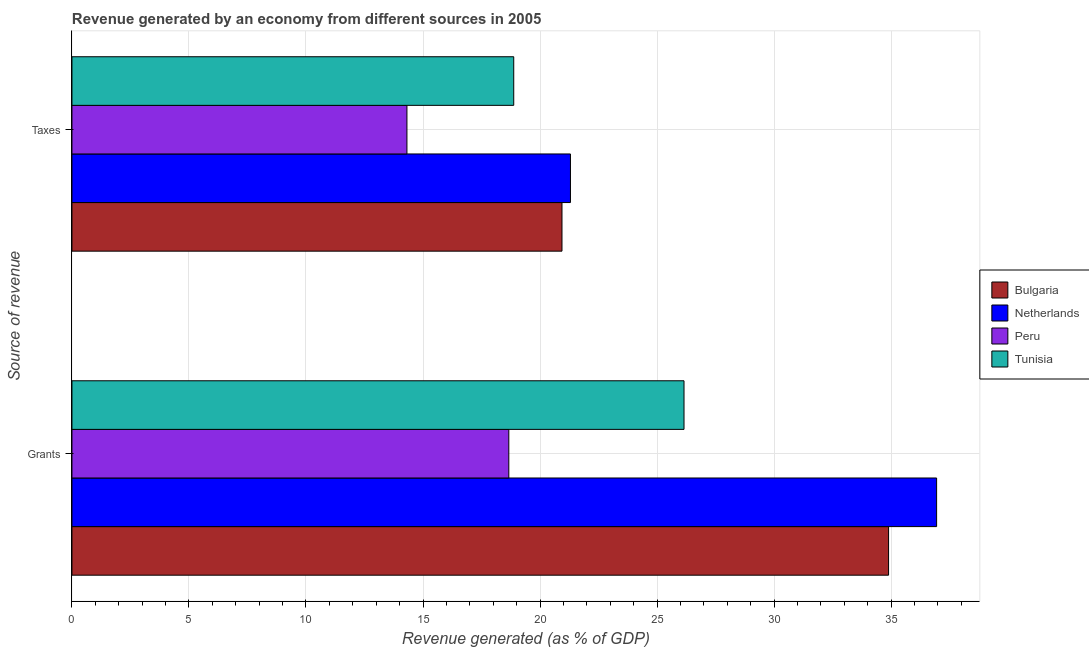Are the number of bars per tick equal to the number of legend labels?
Provide a short and direct response. Yes. How many bars are there on the 1st tick from the top?
Provide a short and direct response. 4. What is the label of the 2nd group of bars from the top?
Your answer should be very brief. Grants. What is the revenue generated by taxes in Peru?
Offer a very short reply. 14.31. Across all countries, what is the maximum revenue generated by grants?
Make the answer very short. 36.95. Across all countries, what is the minimum revenue generated by taxes?
Give a very brief answer. 14.31. What is the total revenue generated by grants in the graph?
Your response must be concise. 116.66. What is the difference between the revenue generated by taxes in Peru and that in Tunisia?
Your answer should be compact. -4.56. What is the difference between the revenue generated by taxes in Peru and the revenue generated by grants in Bulgaria?
Offer a very short reply. -20.58. What is the average revenue generated by grants per country?
Your answer should be compact. 29.17. What is the difference between the revenue generated by grants and revenue generated by taxes in Bulgaria?
Offer a terse response. 13.95. What is the ratio of the revenue generated by taxes in Bulgaria to that in Tunisia?
Your answer should be compact. 1.11. In how many countries, is the revenue generated by taxes greater than the average revenue generated by taxes taken over all countries?
Your response must be concise. 3. What does the 3rd bar from the bottom in Grants represents?
Your response must be concise. Peru. How many bars are there?
Ensure brevity in your answer.  8. Are all the bars in the graph horizontal?
Ensure brevity in your answer.  Yes. How many countries are there in the graph?
Offer a very short reply. 4. Are the values on the major ticks of X-axis written in scientific E-notation?
Offer a terse response. No. Does the graph contain any zero values?
Give a very brief answer. No. Where does the legend appear in the graph?
Give a very brief answer. Center right. How many legend labels are there?
Offer a terse response. 4. How are the legend labels stacked?
Give a very brief answer. Vertical. What is the title of the graph?
Give a very brief answer. Revenue generated by an economy from different sources in 2005. Does "Sierra Leone" appear as one of the legend labels in the graph?
Make the answer very short. No. What is the label or title of the X-axis?
Your response must be concise. Revenue generated (as % of GDP). What is the label or title of the Y-axis?
Keep it short and to the point. Source of revenue. What is the Revenue generated (as % of GDP) of Bulgaria in Grants?
Provide a succinct answer. 34.89. What is the Revenue generated (as % of GDP) of Netherlands in Grants?
Ensure brevity in your answer.  36.95. What is the Revenue generated (as % of GDP) of Peru in Grants?
Your answer should be very brief. 18.67. What is the Revenue generated (as % of GDP) of Tunisia in Grants?
Your answer should be compact. 26.15. What is the Revenue generated (as % of GDP) of Bulgaria in Taxes?
Make the answer very short. 20.94. What is the Revenue generated (as % of GDP) of Netherlands in Taxes?
Make the answer very short. 21.3. What is the Revenue generated (as % of GDP) of Peru in Taxes?
Make the answer very short. 14.31. What is the Revenue generated (as % of GDP) in Tunisia in Taxes?
Provide a short and direct response. 18.88. Across all Source of revenue, what is the maximum Revenue generated (as % of GDP) of Bulgaria?
Keep it short and to the point. 34.89. Across all Source of revenue, what is the maximum Revenue generated (as % of GDP) of Netherlands?
Your answer should be very brief. 36.95. Across all Source of revenue, what is the maximum Revenue generated (as % of GDP) of Peru?
Provide a short and direct response. 18.67. Across all Source of revenue, what is the maximum Revenue generated (as % of GDP) of Tunisia?
Provide a short and direct response. 26.15. Across all Source of revenue, what is the minimum Revenue generated (as % of GDP) of Bulgaria?
Ensure brevity in your answer.  20.94. Across all Source of revenue, what is the minimum Revenue generated (as % of GDP) in Netherlands?
Offer a terse response. 21.3. Across all Source of revenue, what is the minimum Revenue generated (as % of GDP) in Peru?
Your answer should be compact. 14.31. Across all Source of revenue, what is the minimum Revenue generated (as % of GDP) of Tunisia?
Offer a terse response. 18.88. What is the total Revenue generated (as % of GDP) of Bulgaria in the graph?
Provide a short and direct response. 55.83. What is the total Revenue generated (as % of GDP) of Netherlands in the graph?
Your answer should be compact. 58.25. What is the total Revenue generated (as % of GDP) of Peru in the graph?
Provide a short and direct response. 32.98. What is the total Revenue generated (as % of GDP) in Tunisia in the graph?
Give a very brief answer. 45.03. What is the difference between the Revenue generated (as % of GDP) in Bulgaria in Grants and that in Taxes?
Your answer should be very brief. 13.95. What is the difference between the Revenue generated (as % of GDP) of Netherlands in Grants and that in Taxes?
Provide a succinct answer. 15.65. What is the difference between the Revenue generated (as % of GDP) in Peru in Grants and that in Taxes?
Provide a short and direct response. 4.35. What is the difference between the Revenue generated (as % of GDP) of Tunisia in Grants and that in Taxes?
Ensure brevity in your answer.  7.28. What is the difference between the Revenue generated (as % of GDP) of Bulgaria in Grants and the Revenue generated (as % of GDP) of Netherlands in Taxes?
Keep it short and to the point. 13.59. What is the difference between the Revenue generated (as % of GDP) of Bulgaria in Grants and the Revenue generated (as % of GDP) of Peru in Taxes?
Your response must be concise. 20.58. What is the difference between the Revenue generated (as % of GDP) in Bulgaria in Grants and the Revenue generated (as % of GDP) in Tunisia in Taxes?
Your response must be concise. 16.02. What is the difference between the Revenue generated (as % of GDP) of Netherlands in Grants and the Revenue generated (as % of GDP) of Peru in Taxes?
Give a very brief answer. 22.63. What is the difference between the Revenue generated (as % of GDP) of Netherlands in Grants and the Revenue generated (as % of GDP) of Tunisia in Taxes?
Your answer should be compact. 18.07. What is the difference between the Revenue generated (as % of GDP) in Peru in Grants and the Revenue generated (as % of GDP) in Tunisia in Taxes?
Ensure brevity in your answer.  -0.21. What is the average Revenue generated (as % of GDP) of Bulgaria per Source of revenue?
Give a very brief answer. 27.92. What is the average Revenue generated (as % of GDP) of Netherlands per Source of revenue?
Give a very brief answer. 29.12. What is the average Revenue generated (as % of GDP) in Peru per Source of revenue?
Provide a succinct answer. 16.49. What is the average Revenue generated (as % of GDP) in Tunisia per Source of revenue?
Make the answer very short. 22.52. What is the difference between the Revenue generated (as % of GDP) of Bulgaria and Revenue generated (as % of GDP) of Netherlands in Grants?
Your answer should be compact. -2.05. What is the difference between the Revenue generated (as % of GDP) of Bulgaria and Revenue generated (as % of GDP) of Peru in Grants?
Your answer should be compact. 16.23. What is the difference between the Revenue generated (as % of GDP) of Bulgaria and Revenue generated (as % of GDP) of Tunisia in Grants?
Your answer should be very brief. 8.74. What is the difference between the Revenue generated (as % of GDP) in Netherlands and Revenue generated (as % of GDP) in Peru in Grants?
Your response must be concise. 18.28. What is the difference between the Revenue generated (as % of GDP) in Netherlands and Revenue generated (as % of GDP) in Tunisia in Grants?
Provide a succinct answer. 10.79. What is the difference between the Revenue generated (as % of GDP) in Peru and Revenue generated (as % of GDP) in Tunisia in Grants?
Your answer should be very brief. -7.49. What is the difference between the Revenue generated (as % of GDP) in Bulgaria and Revenue generated (as % of GDP) in Netherlands in Taxes?
Make the answer very short. -0.36. What is the difference between the Revenue generated (as % of GDP) of Bulgaria and Revenue generated (as % of GDP) of Peru in Taxes?
Provide a succinct answer. 6.62. What is the difference between the Revenue generated (as % of GDP) of Bulgaria and Revenue generated (as % of GDP) of Tunisia in Taxes?
Provide a succinct answer. 2.06. What is the difference between the Revenue generated (as % of GDP) in Netherlands and Revenue generated (as % of GDP) in Peru in Taxes?
Provide a succinct answer. 6.99. What is the difference between the Revenue generated (as % of GDP) in Netherlands and Revenue generated (as % of GDP) in Tunisia in Taxes?
Offer a very short reply. 2.42. What is the difference between the Revenue generated (as % of GDP) of Peru and Revenue generated (as % of GDP) of Tunisia in Taxes?
Offer a very short reply. -4.56. What is the ratio of the Revenue generated (as % of GDP) in Bulgaria in Grants to that in Taxes?
Provide a short and direct response. 1.67. What is the ratio of the Revenue generated (as % of GDP) of Netherlands in Grants to that in Taxes?
Your response must be concise. 1.73. What is the ratio of the Revenue generated (as % of GDP) in Peru in Grants to that in Taxes?
Ensure brevity in your answer.  1.3. What is the ratio of the Revenue generated (as % of GDP) in Tunisia in Grants to that in Taxes?
Ensure brevity in your answer.  1.39. What is the difference between the highest and the second highest Revenue generated (as % of GDP) of Bulgaria?
Your answer should be compact. 13.95. What is the difference between the highest and the second highest Revenue generated (as % of GDP) in Netherlands?
Provide a succinct answer. 15.65. What is the difference between the highest and the second highest Revenue generated (as % of GDP) of Peru?
Provide a succinct answer. 4.35. What is the difference between the highest and the second highest Revenue generated (as % of GDP) of Tunisia?
Your answer should be very brief. 7.28. What is the difference between the highest and the lowest Revenue generated (as % of GDP) of Bulgaria?
Your answer should be compact. 13.95. What is the difference between the highest and the lowest Revenue generated (as % of GDP) in Netherlands?
Offer a terse response. 15.65. What is the difference between the highest and the lowest Revenue generated (as % of GDP) in Peru?
Offer a very short reply. 4.35. What is the difference between the highest and the lowest Revenue generated (as % of GDP) of Tunisia?
Give a very brief answer. 7.28. 